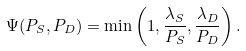Convert formula to latex. <formula><loc_0><loc_0><loc_500><loc_500>\Psi ( P _ { S } , P _ { D } ) = \min \left ( 1 , \frac { \lambda _ { S } } { P _ { S } } , \frac { \lambda _ { D } } { P _ { D } } \right ) .</formula> 